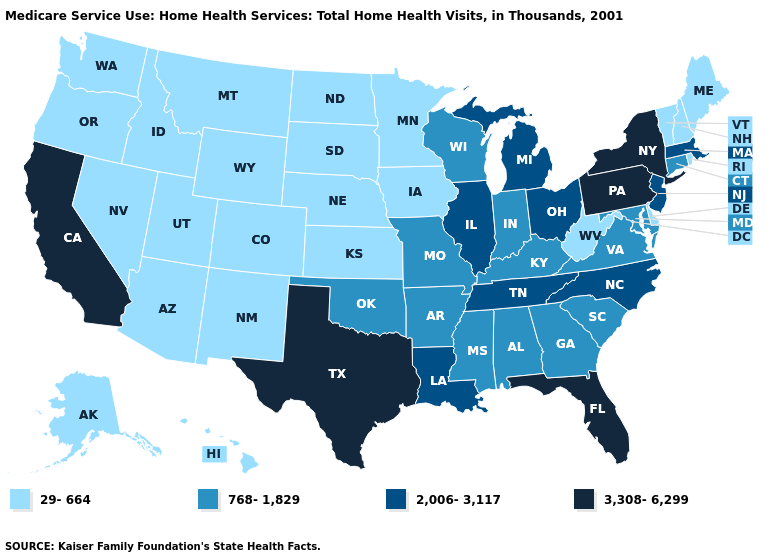Name the states that have a value in the range 768-1,829?
Write a very short answer. Alabama, Arkansas, Connecticut, Georgia, Indiana, Kentucky, Maryland, Mississippi, Missouri, Oklahoma, South Carolina, Virginia, Wisconsin. Which states have the lowest value in the USA?
Give a very brief answer. Alaska, Arizona, Colorado, Delaware, Hawaii, Idaho, Iowa, Kansas, Maine, Minnesota, Montana, Nebraska, Nevada, New Hampshire, New Mexico, North Dakota, Oregon, Rhode Island, South Dakota, Utah, Vermont, Washington, West Virginia, Wyoming. What is the lowest value in the West?
Short answer required. 29-664. What is the value of Georgia?
Quick response, please. 768-1,829. Does North Carolina have the highest value in the USA?
Write a very short answer. No. What is the value of Virginia?
Quick response, please. 768-1,829. Does the map have missing data?
Quick response, please. No. What is the value of Montana?
Keep it brief. 29-664. Name the states that have a value in the range 2,006-3,117?
Give a very brief answer. Illinois, Louisiana, Massachusetts, Michigan, New Jersey, North Carolina, Ohio, Tennessee. Does Illinois have the highest value in the MidWest?
Short answer required. Yes. Which states have the lowest value in the USA?
Short answer required. Alaska, Arizona, Colorado, Delaware, Hawaii, Idaho, Iowa, Kansas, Maine, Minnesota, Montana, Nebraska, Nevada, New Hampshire, New Mexico, North Dakota, Oregon, Rhode Island, South Dakota, Utah, Vermont, Washington, West Virginia, Wyoming. Name the states that have a value in the range 2,006-3,117?
Short answer required. Illinois, Louisiana, Massachusetts, Michigan, New Jersey, North Carolina, Ohio, Tennessee. What is the lowest value in states that border Louisiana?
Be succinct. 768-1,829. Among the states that border Idaho , which have the lowest value?
Answer briefly. Montana, Nevada, Oregon, Utah, Washington, Wyoming. Does Washington have a higher value than Minnesota?
Be succinct. No. 